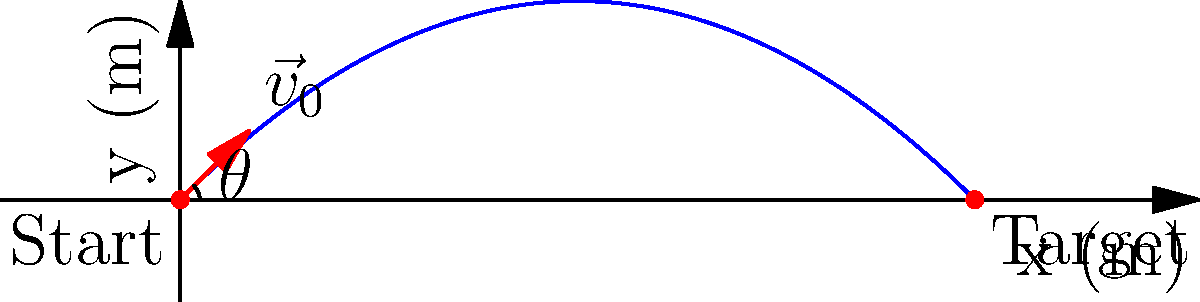In a stealth mission, Snake needs to throw a grenade at an enemy target. The initial velocity of the grenade is 20 m/s at a 45-degree angle from the horizontal. Assuming no air resistance, what is the horizontal distance the grenade will travel before hitting the ground? To solve this problem, we'll use the equations of projectile motion:

1) First, let's identify the known variables:
   - Initial velocity, $v_0 = 20$ m/s
   - Angle of launch, $\theta = 45°$
   - Acceleration due to gravity, $g = 9.8$ m/s²

2) The horizontal distance (range) of a projectile is given by the formula:
   $$R = \frac{v_0^2 \sin(2\theta)}{g}$$

3) We know that $\sin(2\theta) = \sin(90°) = 1$ when $\theta = 45°$, so our equation simplifies to:
   $$R = \frac{v_0^2}{g}$$

4) Now, let's substitute our known values:
   $$R = \frac{(20 \text{ m/s})^2}{9.8 \text{ m/s}^2}$$

5) Calculate:
   $$R = \frac{400 \text{ m}^2\text{/s}^2}{9.8 \text{ m/s}^2} \approx 40.82 \text{ m}$$

Therefore, the grenade will travel approximately 40.82 meters horizontally before hitting the ground.
Answer: 40.82 m 